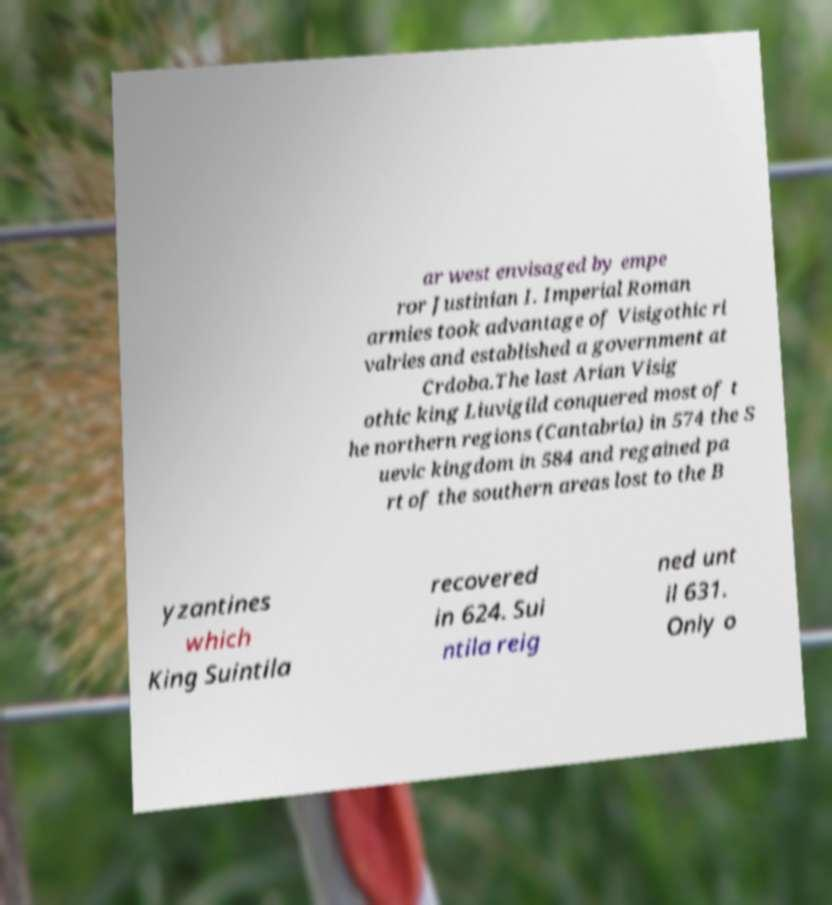For documentation purposes, I need the text within this image transcribed. Could you provide that? ar west envisaged by empe ror Justinian I. Imperial Roman armies took advantage of Visigothic ri valries and established a government at Crdoba.The last Arian Visig othic king Liuvigild conquered most of t he northern regions (Cantabria) in 574 the S uevic kingdom in 584 and regained pa rt of the southern areas lost to the B yzantines which King Suintila recovered in 624. Sui ntila reig ned unt il 631. Only o 